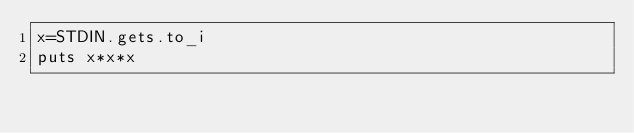Convert code to text. <code><loc_0><loc_0><loc_500><loc_500><_Ruby_>x=STDIN.gets.to_i
puts x*x*x</code> 